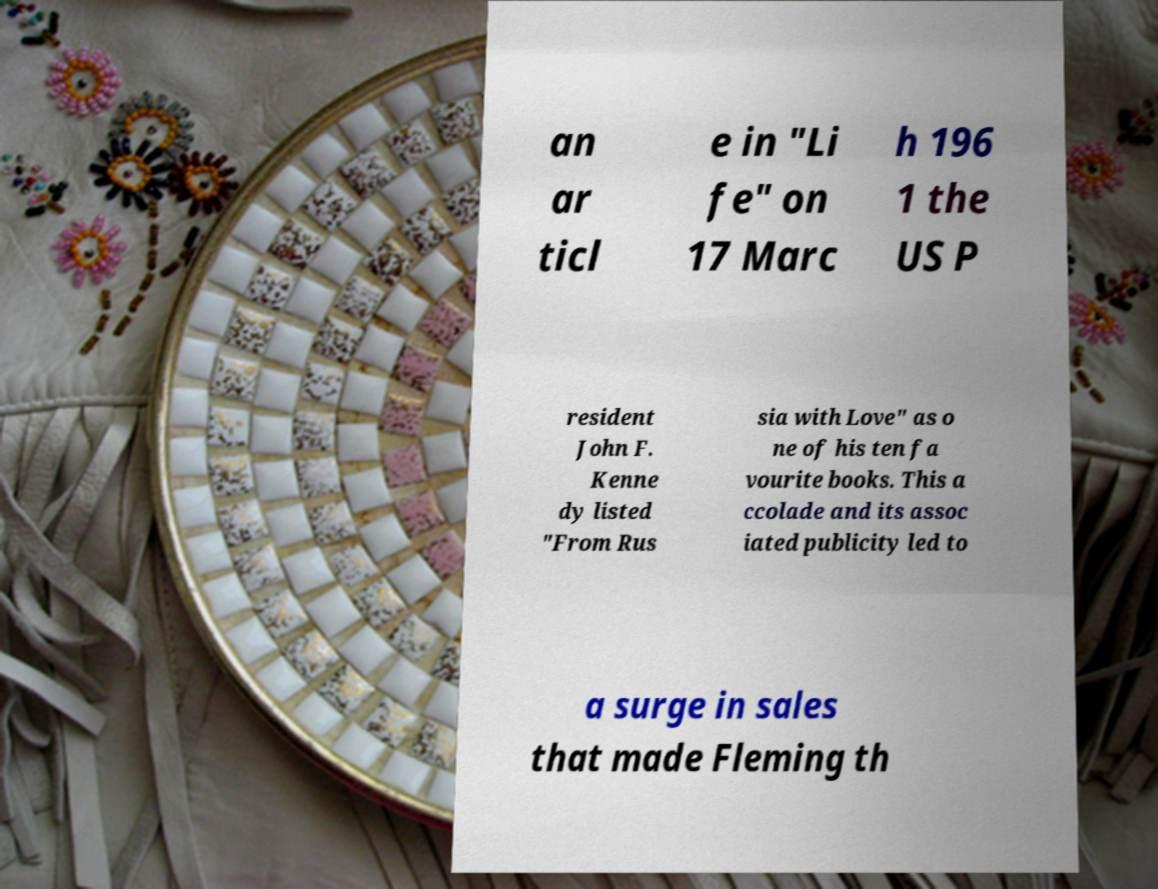Can you accurately transcribe the text from the provided image for me? an ar ticl e in "Li fe" on 17 Marc h 196 1 the US P resident John F. Kenne dy listed "From Rus sia with Love" as o ne of his ten fa vourite books. This a ccolade and its assoc iated publicity led to a surge in sales that made Fleming th 